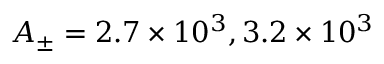<formula> <loc_0><loc_0><loc_500><loc_500>A _ { \pm } = 2 . 7 \times 1 0 ^ { 3 } , 3 . 2 \times 1 0 ^ { 3 }</formula> 